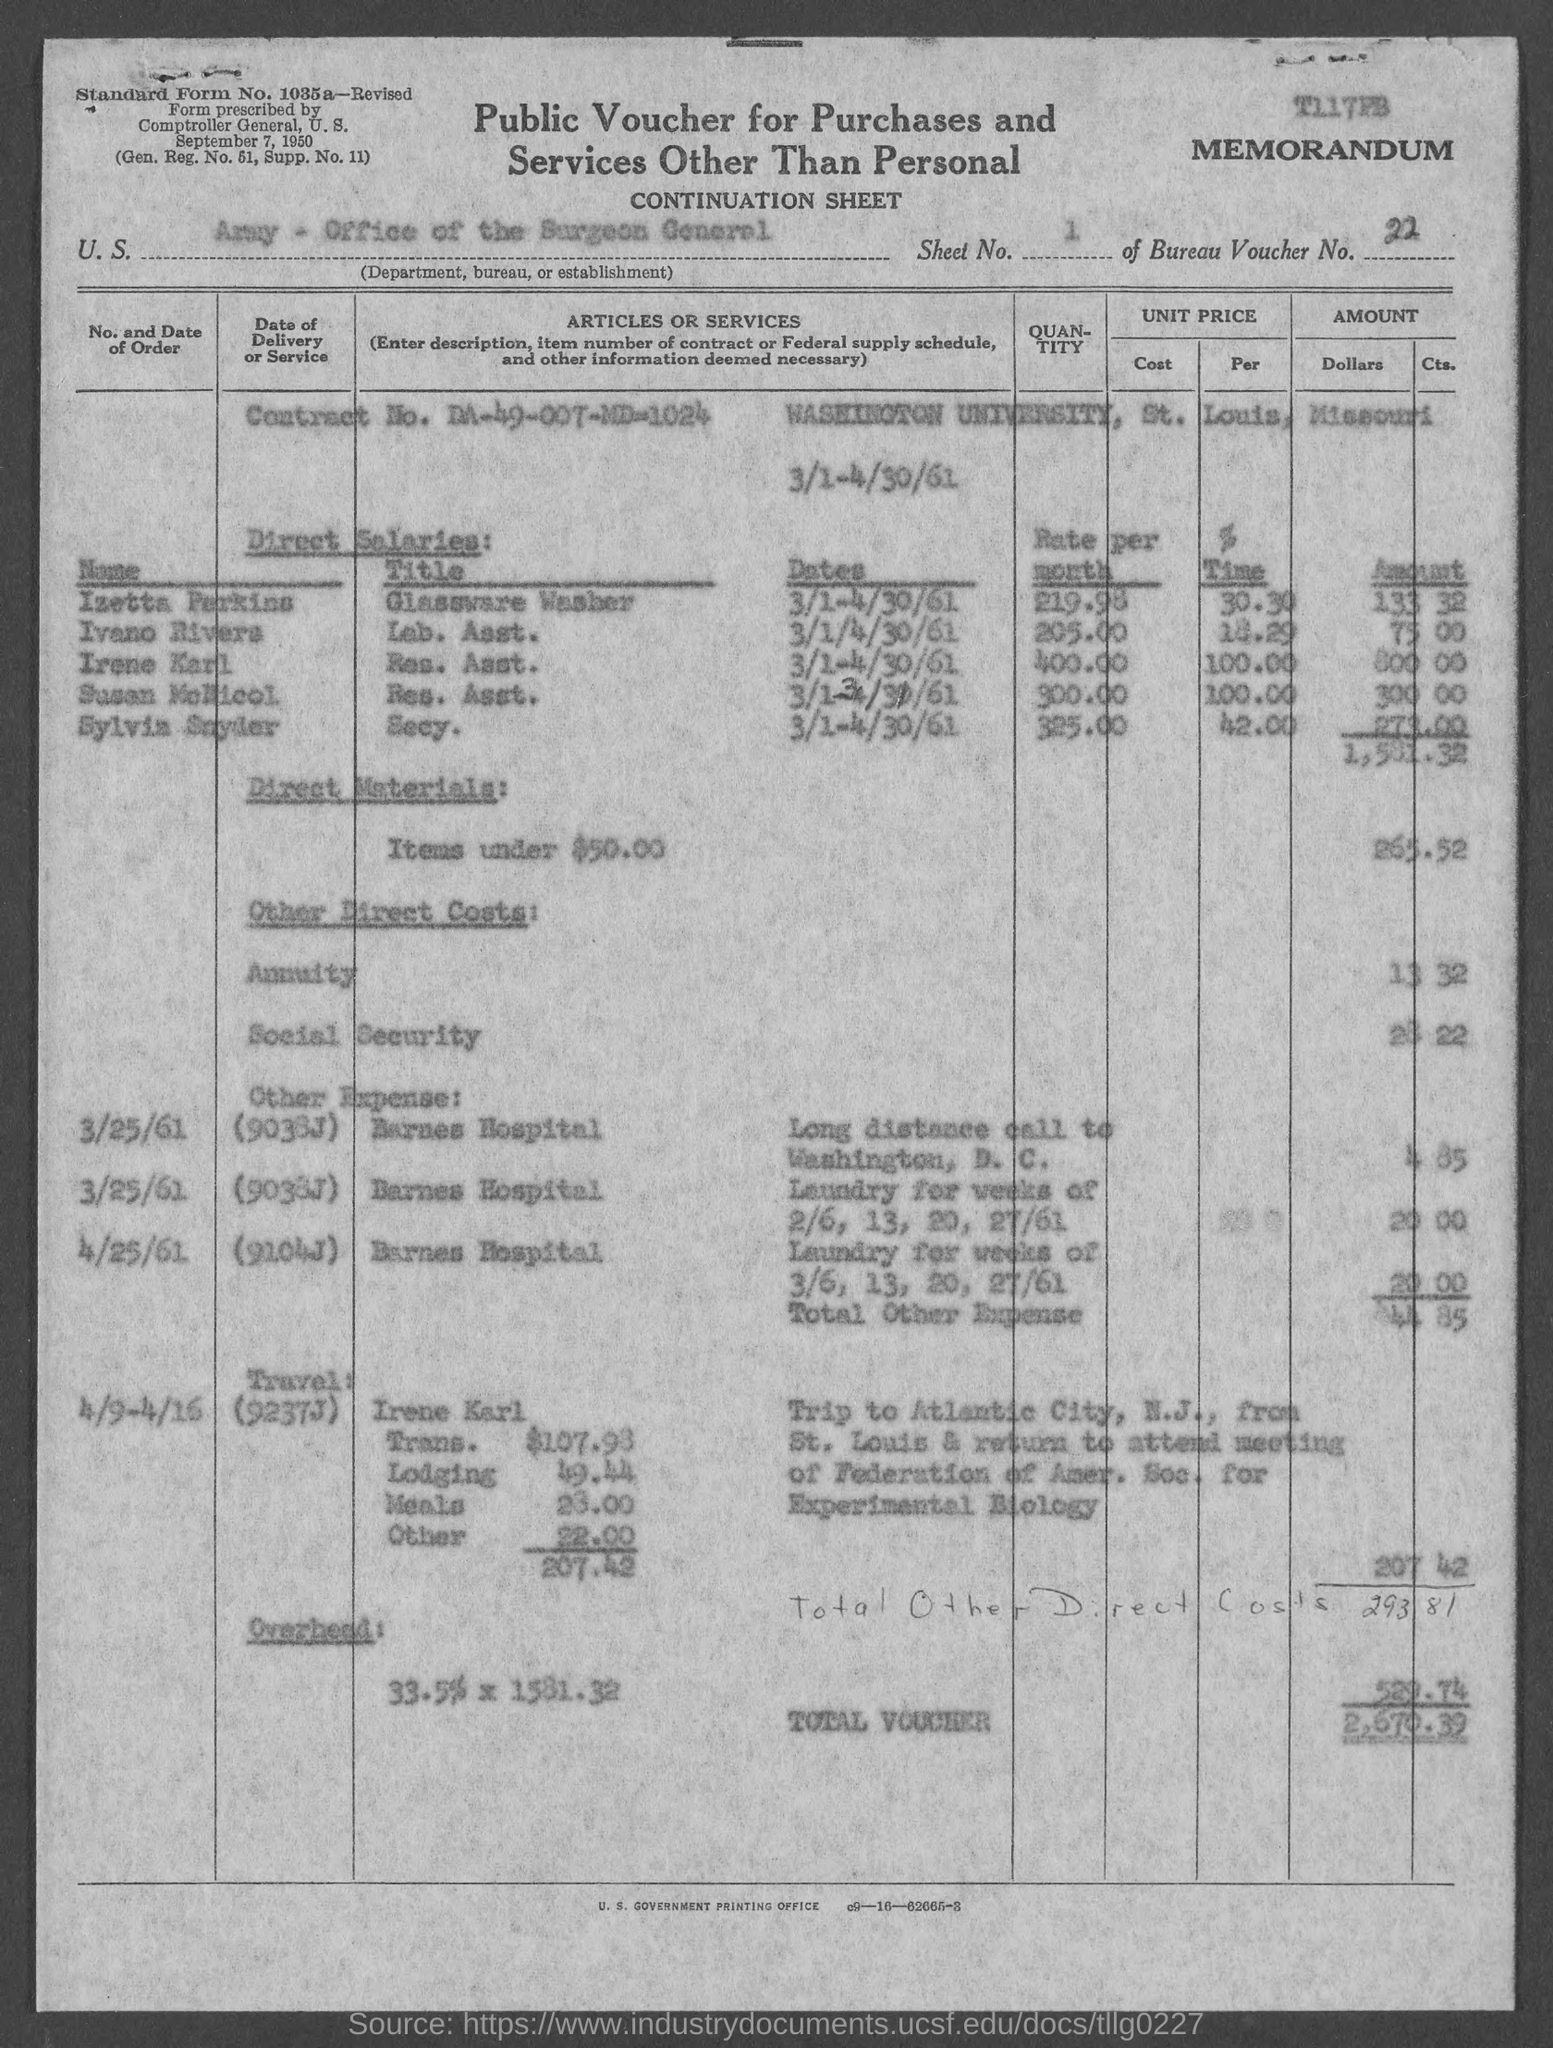What is the sheet no.?
Your answer should be very brief. 1. What is the bureau voucher no.?
Ensure brevity in your answer.  22. What is the total voucher amount ?
Offer a very short reply. 2,670.39. What is the contract no.?
Provide a short and direct response. DA-49-007-MD-1024. 